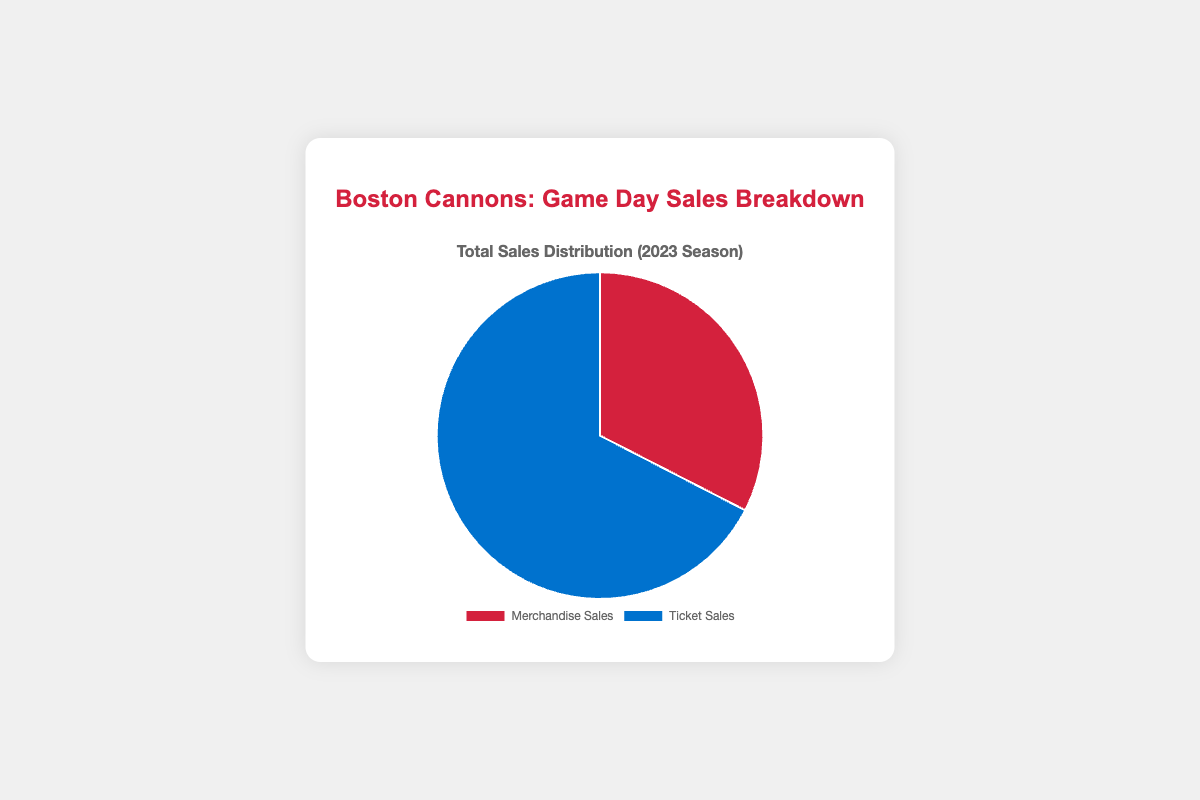What percentage of total sales is represented by merchandise sales? Merchandise sales are $70,000 and the total sales are $70,000 (merchandise) + $145,000 (tickets) = $215,000. The percentage for merchandise sales is (70,000 / 215,000) * 100 = 32.56%.
Answer: 32.56% Which category has higher sales, merchandise or tickets? The pie chart shows that the data point for ticket sales is larger. Ticket sales are $145,000 and merchandise sales are $70,000, so ticket sales are higher.
Answer: Tickets What is the total amount of sales for the season? Summing the merchandise sales ($70,000) and ticket sales ($145,000) gives the total sales: $70,000 + $145,000 = $215,000.
Answer: $215,000 By how much do ticket sales exceed merchandise sales? Ticket sales are $145,000 and merchandise sales are $70,000. The difference is $145,000 - $70,000 = $75,000.
Answer: $75,000 What is the ratio of merchandise sales to ticket sales? The ratio of merchandise sales to ticket sales is $70,000 : $145,000, which simplifies to 70:145 or 7:14, further simplified to 1:2.
Answer: 1:2 What percentage of the total sales is represented by ticket sales? Ticket sales are $145,000 and the total sales are $215,000. The percentage for ticket sales is (145,000 / 215,000) * 100 = 67.44%.
Answer: 67.44% What is the color representing merchandise sales in the chart? The color for merchandise sales is clearly shown in red in the pie chart.
Answer: Red 